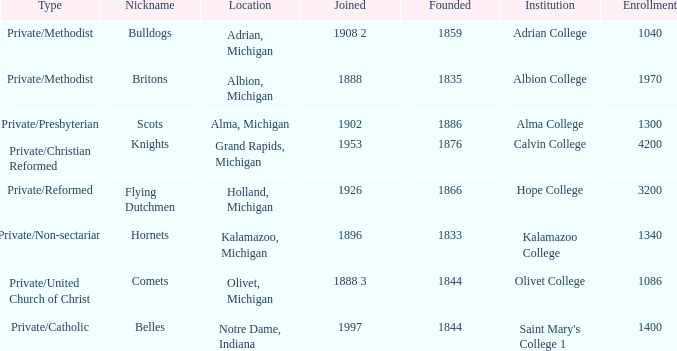How many categories fall under the category of britons? 1.0. 